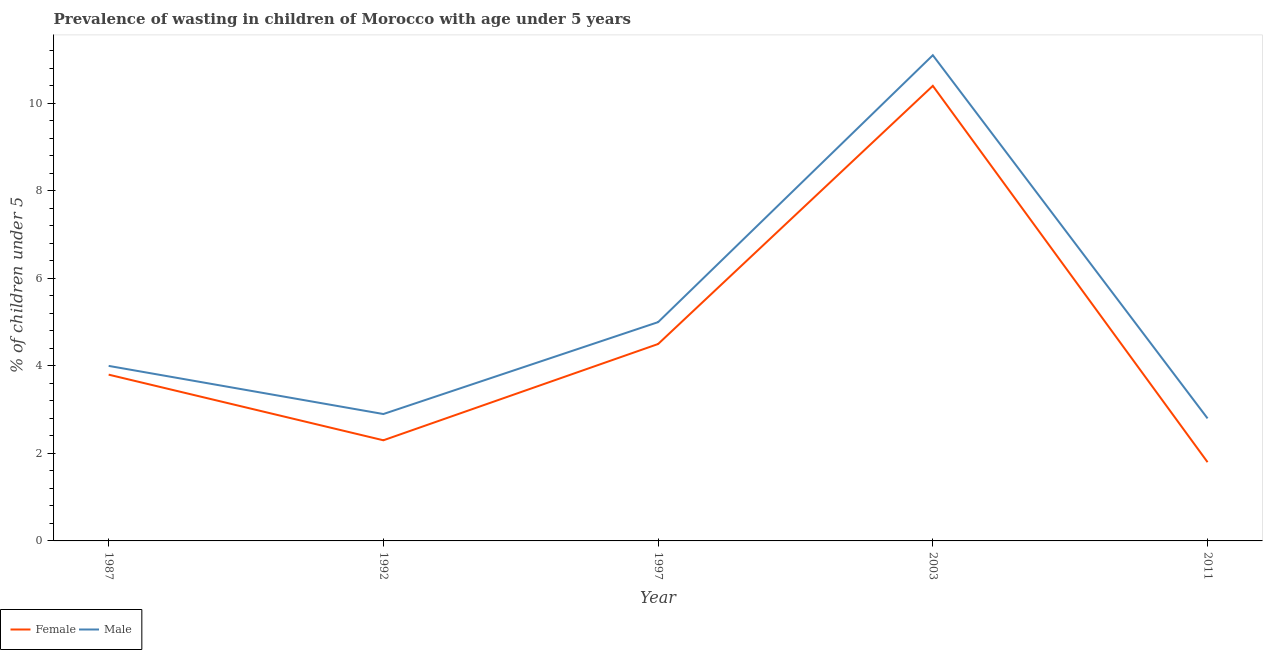How many different coloured lines are there?
Give a very brief answer. 2. Is the number of lines equal to the number of legend labels?
Your answer should be very brief. Yes. What is the percentage of undernourished male children in 1997?
Your response must be concise. 5. Across all years, what is the maximum percentage of undernourished female children?
Ensure brevity in your answer.  10.4. Across all years, what is the minimum percentage of undernourished female children?
Your answer should be very brief. 1.8. In which year was the percentage of undernourished male children maximum?
Your answer should be compact. 2003. What is the total percentage of undernourished female children in the graph?
Provide a succinct answer. 22.8. What is the difference between the percentage of undernourished female children in 1987 and that in 1992?
Provide a short and direct response. 1.5. What is the difference between the percentage of undernourished female children in 1987 and the percentage of undernourished male children in 1997?
Your answer should be very brief. -1.2. What is the average percentage of undernourished male children per year?
Offer a very short reply. 5.16. In the year 1992, what is the difference between the percentage of undernourished female children and percentage of undernourished male children?
Provide a succinct answer. -0.6. What is the ratio of the percentage of undernourished female children in 1992 to that in 1997?
Offer a terse response. 0.51. What is the difference between the highest and the second highest percentage of undernourished female children?
Your answer should be compact. 5.9. What is the difference between the highest and the lowest percentage of undernourished female children?
Keep it short and to the point. 8.6. In how many years, is the percentage of undernourished male children greater than the average percentage of undernourished male children taken over all years?
Offer a terse response. 1. Is the sum of the percentage of undernourished male children in 2003 and 2011 greater than the maximum percentage of undernourished female children across all years?
Offer a very short reply. Yes. Is the percentage of undernourished female children strictly less than the percentage of undernourished male children over the years?
Offer a very short reply. Yes. How many lines are there?
Give a very brief answer. 2. Are the values on the major ticks of Y-axis written in scientific E-notation?
Provide a short and direct response. No. Does the graph contain any zero values?
Offer a terse response. No. Where does the legend appear in the graph?
Offer a terse response. Bottom left. How many legend labels are there?
Offer a terse response. 2. How are the legend labels stacked?
Provide a short and direct response. Horizontal. What is the title of the graph?
Make the answer very short. Prevalence of wasting in children of Morocco with age under 5 years. Does "Investment" appear as one of the legend labels in the graph?
Offer a very short reply. No. What is the label or title of the X-axis?
Provide a short and direct response. Year. What is the label or title of the Y-axis?
Your answer should be very brief.  % of children under 5. What is the  % of children under 5 of Female in 1987?
Offer a terse response. 3.8. What is the  % of children under 5 in Female in 1992?
Make the answer very short. 2.3. What is the  % of children under 5 of Male in 1992?
Provide a succinct answer. 2.9. What is the  % of children under 5 in Male in 1997?
Your answer should be compact. 5. What is the  % of children under 5 in Female in 2003?
Ensure brevity in your answer.  10.4. What is the  % of children under 5 in Male in 2003?
Provide a short and direct response. 11.1. What is the  % of children under 5 in Female in 2011?
Your answer should be compact. 1.8. What is the  % of children under 5 in Male in 2011?
Make the answer very short. 2.8. Across all years, what is the maximum  % of children under 5 of Female?
Ensure brevity in your answer.  10.4. Across all years, what is the maximum  % of children under 5 in Male?
Give a very brief answer. 11.1. Across all years, what is the minimum  % of children under 5 of Female?
Offer a terse response. 1.8. Across all years, what is the minimum  % of children under 5 in Male?
Your response must be concise. 2.8. What is the total  % of children under 5 in Female in the graph?
Your answer should be very brief. 22.8. What is the total  % of children under 5 of Male in the graph?
Your answer should be compact. 25.8. What is the difference between the  % of children under 5 in Female in 1987 and that in 1992?
Offer a very short reply. 1.5. What is the difference between the  % of children under 5 of Male in 1987 and that in 2011?
Your answer should be very brief. 1.2. What is the difference between the  % of children under 5 in Male in 1992 and that in 1997?
Offer a terse response. -2.1. What is the difference between the  % of children under 5 in Male in 1992 and that in 2003?
Give a very brief answer. -8.2. What is the difference between the  % of children under 5 of Female in 1992 and that in 2011?
Make the answer very short. 0.5. What is the difference between the  % of children under 5 in Female in 1997 and that in 2003?
Offer a very short reply. -5.9. What is the difference between the  % of children under 5 in Male in 2003 and that in 2011?
Keep it short and to the point. 8.3. What is the difference between the  % of children under 5 of Female in 1987 and the  % of children under 5 of Male in 1997?
Your response must be concise. -1.2. What is the difference between the  % of children under 5 of Female in 1987 and the  % of children under 5 of Male in 2011?
Keep it short and to the point. 1. What is the difference between the  % of children under 5 of Female in 1992 and the  % of children under 5 of Male in 1997?
Make the answer very short. -2.7. What is the difference between the  % of children under 5 in Female in 1992 and the  % of children under 5 in Male in 2011?
Ensure brevity in your answer.  -0.5. What is the difference between the  % of children under 5 in Female in 1997 and the  % of children under 5 in Male in 2003?
Keep it short and to the point. -6.6. What is the difference between the  % of children under 5 of Female in 1997 and the  % of children under 5 of Male in 2011?
Provide a succinct answer. 1.7. What is the difference between the  % of children under 5 of Female in 2003 and the  % of children under 5 of Male in 2011?
Provide a succinct answer. 7.6. What is the average  % of children under 5 of Female per year?
Your answer should be compact. 4.56. What is the average  % of children under 5 of Male per year?
Offer a terse response. 5.16. In the year 1987, what is the difference between the  % of children under 5 in Female and  % of children under 5 in Male?
Ensure brevity in your answer.  -0.2. In the year 1992, what is the difference between the  % of children under 5 of Female and  % of children under 5 of Male?
Make the answer very short. -0.6. What is the ratio of the  % of children under 5 in Female in 1987 to that in 1992?
Offer a very short reply. 1.65. What is the ratio of the  % of children under 5 of Male in 1987 to that in 1992?
Provide a succinct answer. 1.38. What is the ratio of the  % of children under 5 of Female in 1987 to that in 1997?
Offer a terse response. 0.84. What is the ratio of the  % of children under 5 in Male in 1987 to that in 1997?
Offer a very short reply. 0.8. What is the ratio of the  % of children under 5 of Female in 1987 to that in 2003?
Make the answer very short. 0.37. What is the ratio of the  % of children under 5 of Male in 1987 to that in 2003?
Your response must be concise. 0.36. What is the ratio of the  % of children under 5 of Female in 1987 to that in 2011?
Provide a succinct answer. 2.11. What is the ratio of the  % of children under 5 of Male in 1987 to that in 2011?
Make the answer very short. 1.43. What is the ratio of the  % of children under 5 of Female in 1992 to that in 1997?
Provide a succinct answer. 0.51. What is the ratio of the  % of children under 5 of Male in 1992 to that in 1997?
Your answer should be very brief. 0.58. What is the ratio of the  % of children under 5 in Female in 1992 to that in 2003?
Ensure brevity in your answer.  0.22. What is the ratio of the  % of children under 5 in Male in 1992 to that in 2003?
Your answer should be compact. 0.26. What is the ratio of the  % of children under 5 in Female in 1992 to that in 2011?
Your response must be concise. 1.28. What is the ratio of the  % of children under 5 in Male in 1992 to that in 2011?
Provide a succinct answer. 1.04. What is the ratio of the  % of children under 5 of Female in 1997 to that in 2003?
Your response must be concise. 0.43. What is the ratio of the  % of children under 5 in Male in 1997 to that in 2003?
Provide a succinct answer. 0.45. What is the ratio of the  % of children under 5 in Female in 1997 to that in 2011?
Offer a very short reply. 2.5. What is the ratio of the  % of children under 5 of Male in 1997 to that in 2011?
Provide a succinct answer. 1.79. What is the ratio of the  % of children under 5 in Female in 2003 to that in 2011?
Offer a very short reply. 5.78. What is the ratio of the  % of children under 5 in Male in 2003 to that in 2011?
Keep it short and to the point. 3.96. What is the difference between the highest and the second highest  % of children under 5 of Female?
Your answer should be compact. 5.9. What is the difference between the highest and the second highest  % of children under 5 of Male?
Offer a terse response. 6.1. What is the difference between the highest and the lowest  % of children under 5 of Male?
Keep it short and to the point. 8.3. 